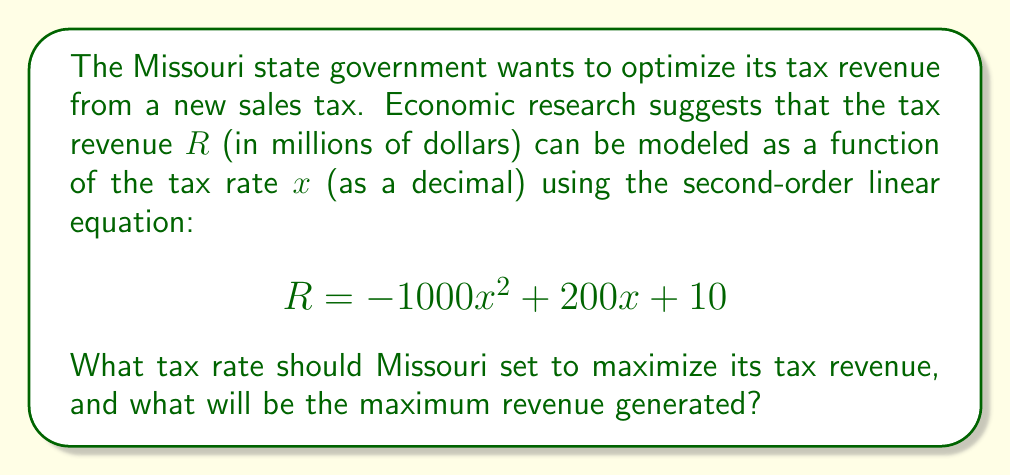Solve this math problem. To solve this problem, we need to follow these steps:

1) The given equation is a quadratic function. To find the maximum value, we need to find the vertex of the parabola.

2) For a quadratic function in the form $f(x) = ax^2 + bx + c$, the x-coordinate of the vertex is given by $x = -\frac{b}{2a}$.

3) In our equation, $R = -1000x^2 + 200x + 10$, we have:
   $a = -1000$
   $b = 200$
   $c = 10$

4) Applying the formula:

   $x = -\frac{b}{2a} = -\frac{200}{2(-1000)} = \frac{200}{2000} = 0.1$

5) This means the optimal tax rate is 0.1 or 10%.

6) To find the maximum revenue, we substitute this x-value back into the original equation:

   $R = -1000(0.1)^2 + 200(0.1) + 10$
   $R = -10 + 20 + 10$
   $R = 20$

Therefore, the maximum revenue is $20 million.
Answer: The optimal tax rate is 10% (0.1), which will generate a maximum revenue of $20 million. 